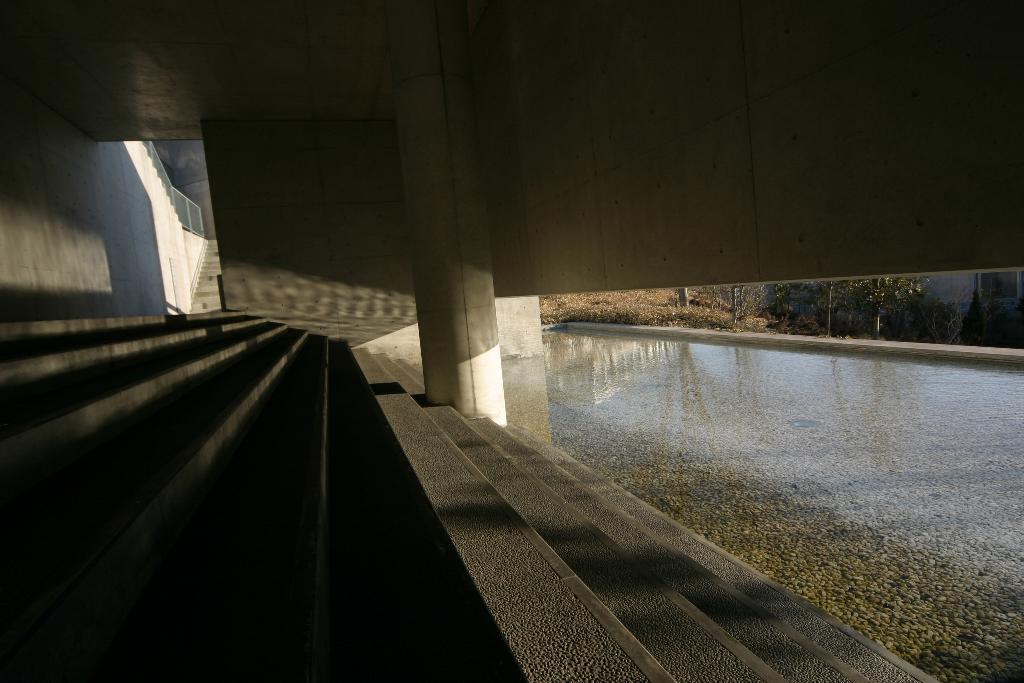What architectural feature is present at the front of the image? There are steps in the front of the image. What natural element can be seen on the right side of the image? There is water visible on the right side of the image. What type of vegetation is present in the image? There are trees in the image. What structure can be seen in the background of the image? There is a wall visible in the background of the image. How much debt is visible in the image? There is no mention of debt in the image, as it features steps, water, trees, and a wall. What type of steam can be seen coming from the trees in the image? There is no steam present in the image; it features steps, water, trees, and a wall. 